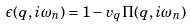<formula> <loc_0><loc_0><loc_500><loc_500>\epsilon ( q , i \omega _ { n } ) = 1 - v _ { q } \Pi ( q , i \omega _ { n } )</formula> 